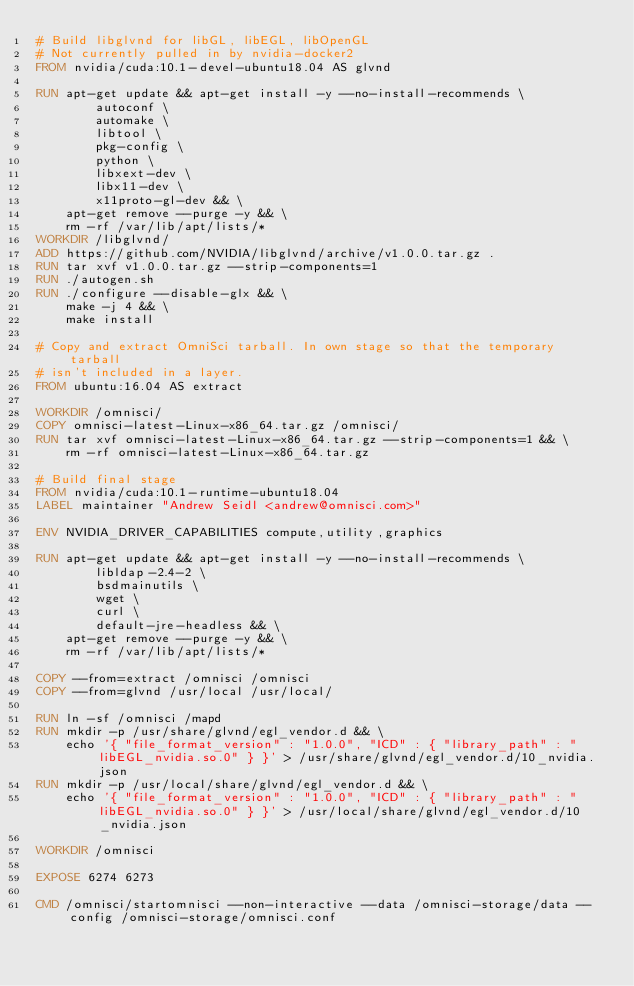Convert code to text. <code><loc_0><loc_0><loc_500><loc_500><_Dockerfile_># Build libglvnd for libGL, libEGL, libOpenGL
# Not currently pulled in by nvidia-docker2
FROM nvidia/cuda:10.1-devel-ubuntu18.04 AS glvnd

RUN apt-get update && apt-get install -y --no-install-recommends \
        autoconf \
        automake \
        libtool \
        pkg-config \
        python \
        libxext-dev \
        libx11-dev \
        x11proto-gl-dev && \
    apt-get remove --purge -y && \
    rm -rf /var/lib/apt/lists/*
WORKDIR /libglvnd/
ADD https://github.com/NVIDIA/libglvnd/archive/v1.0.0.tar.gz .
RUN tar xvf v1.0.0.tar.gz --strip-components=1
RUN ./autogen.sh
RUN ./configure --disable-glx && \
    make -j 4 && \
    make install

# Copy and extract OmniSci tarball. In own stage so that the temporary tarball
# isn't included in a layer.
FROM ubuntu:16.04 AS extract

WORKDIR /omnisci/
COPY omnisci-latest-Linux-x86_64.tar.gz /omnisci/
RUN tar xvf omnisci-latest-Linux-x86_64.tar.gz --strip-components=1 && \
    rm -rf omnisci-latest-Linux-x86_64.tar.gz

# Build final stage
FROM nvidia/cuda:10.1-runtime-ubuntu18.04
LABEL maintainer "Andrew Seidl <andrew@omnisci.com>"

ENV NVIDIA_DRIVER_CAPABILITIES compute,utility,graphics

RUN apt-get update && apt-get install -y --no-install-recommends \
        libldap-2.4-2 \
        bsdmainutils \
        wget \
        curl \
        default-jre-headless && \
    apt-get remove --purge -y && \
    rm -rf /var/lib/apt/lists/*

COPY --from=extract /omnisci /omnisci
COPY --from=glvnd /usr/local /usr/local/

RUN ln -sf /omnisci /mapd
RUN mkdir -p /usr/share/glvnd/egl_vendor.d && \
    echo '{ "file_format_version" : "1.0.0", "ICD" : { "library_path" : "libEGL_nvidia.so.0" } }' > /usr/share/glvnd/egl_vendor.d/10_nvidia.json
RUN mkdir -p /usr/local/share/glvnd/egl_vendor.d && \
    echo '{ "file_format_version" : "1.0.0", "ICD" : { "library_path" : "libEGL_nvidia.so.0" } }' > /usr/local/share/glvnd/egl_vendor.d/10_nvidia.json

WORKDIR /omnisci

EXPOSE 6274 6273

CMD /omnisci/startomnisci --non-interactive --data /omnisci-storage/data --config /omnisci-storage/omnisci.conf
</code> 